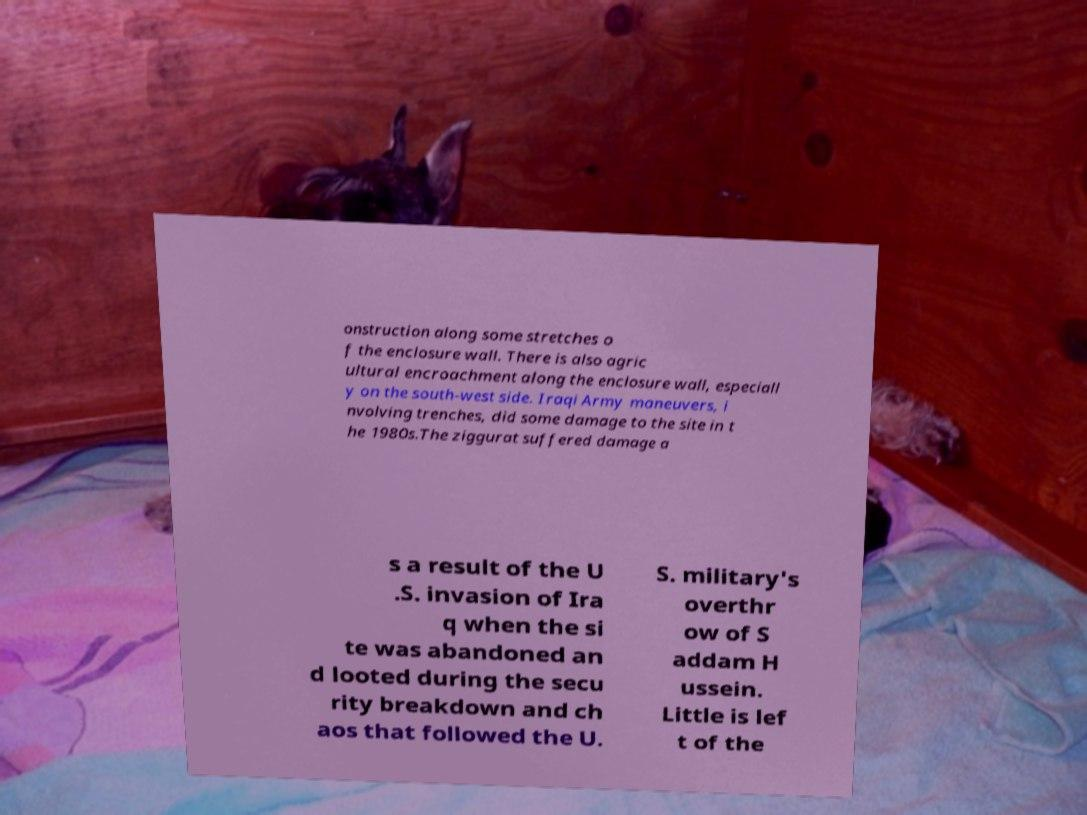Could you extract and type out the text from this image? onstruction along some stretches o f the enclosure wall. There is also agric ultural encroachment along the enclosure wall, especiall y on the south-west side. Iraqi Army maneuvers, i nvolving trenches, did some damage to the site in t he 1980s.The ziggurat suffered damage a s a result of the U .S. invasion of Ira q when the si te was abandoned an d looted during the secu rity breakdown and ch aos that followed the U. S. military's overthr ow of S addam H ussein. Little is lef t of the 